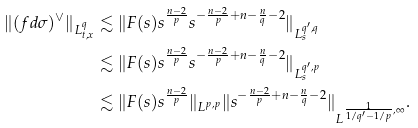Convert formula to latex. <formula><loc_0><loc_0><loc_500><loc_500>\| ( f d \sigma ) ^ { \vee } \| _ { L ^ { q } _ { t , x } } & \lesssim \| F ( s ) s ^ { \frac { n - 2 } { p } } s ^ { - \frac { n - 2 } { p } + n - \frac { n } { q } - 2 } \| _ { L ^ { q ^ { \prime } , q } _ { s } } \\ & \lesssim \| F ( s ) s ^ { \frac { n - 2 } { p } } s ^ { - \frac { n - 2 } { p } + n - \frac { n } { q } - 2 } \| _ { L ^ { q ^ { \prime } , p } _ { s } } \\ & \lesssim \| F ( s ) s ^ { \frac { n - 2 } { p } } \| _ { L ^ { p , p } } \| s ^ { - \frac { n - 2 } { p } + n - \frac { n } { q } - 2 } \| _ { L ^ { \frac { 1 } { 1 / q ^ { \prime } - 1 / p } , \infty } } .</formula> 